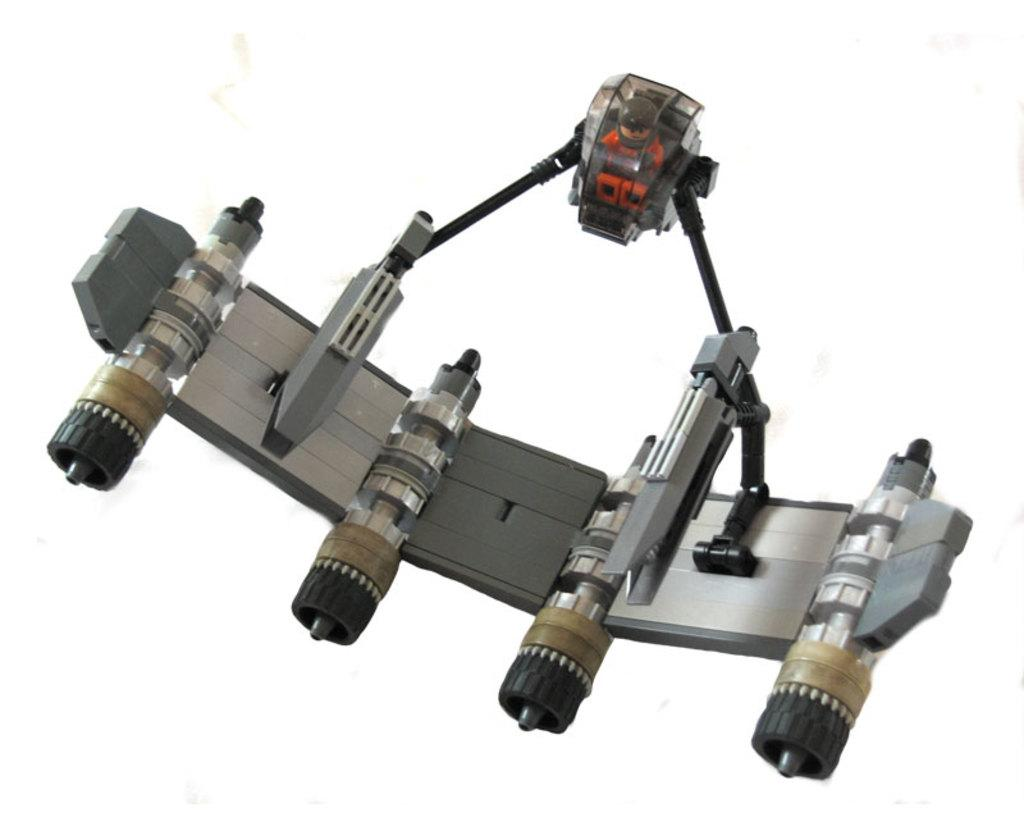What is the main subject of the image? There is an object in the middle of the image. What color is the background of the image? The background of the image is white. What type of crayon is being used to draw on the church in the image? There is no church or crayon present in the image. 